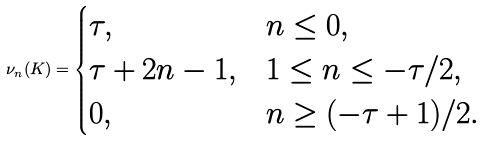Convert formula to latex. <formula><loc_0><loc_0><loc_500><loc_500>\nu _ { n } ( K ) = \begin{cases} \tau , & n \leq 0 , \\ \tau + 2 n - 1 , & 1 \leq n \leq - \tau / 2 , \\ 0 , & n \geq ( - \tau + 1 ) / 2 . \end{cases}</formula> 